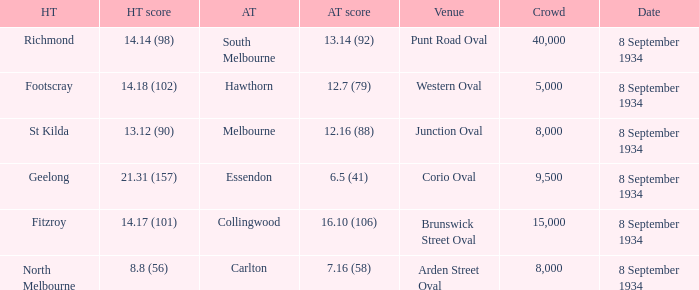I'm looking to parse the entire table for insights. Could you assist me with that? {'header': ['HT', 'HT score', 'AT', 'AT score', 'Venue', 'Crowd', 'Date'], 'rows': [['Richmond', '14.14 (98)', 'South Melbourne', '13.14 (92)', 'Punt Road Oval', '40,000', '8 September 1934'], ['Footscray', '14.18 (102)', 'Hawthorn', '12.7 (79)', 'Western Oval', '5,000', '8 September 1934'], ['St Kilda', '13.12 (90)', 'Melbourne', '12.16 (88)', 'Junction Oval', '8,000', '8 September 1934'], ['Geelong', '21.31 (157)', 'Essendon', '6.5 (41)', 'Corio Oval', '9,500', '8 September 1934'], ['Fitzroy', '14.17 (101)', 'Collingwood', '16.10 (106)', 'Brunswick Street Oval', '15,000', '8 September 1934'], ['North Melbourne', '8.8 (56)', 'Carlton', '7.16 (58)', 'Arden Street Oval', '8,000', '8 September 1934']]} When the Home team scored 14.14 (98), what did the Away Team score? 13.14 (92). 